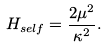<formula> <loc_0><loc_0><loc_500><loc_500>H _ { s e l f } = \frac { 2 \mu ^ { 2 } } { \kappa ^ { 2 } } .</formula> 